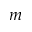<formula> <loc_0><loc_0><loc_500><loc_500>m</formula> 